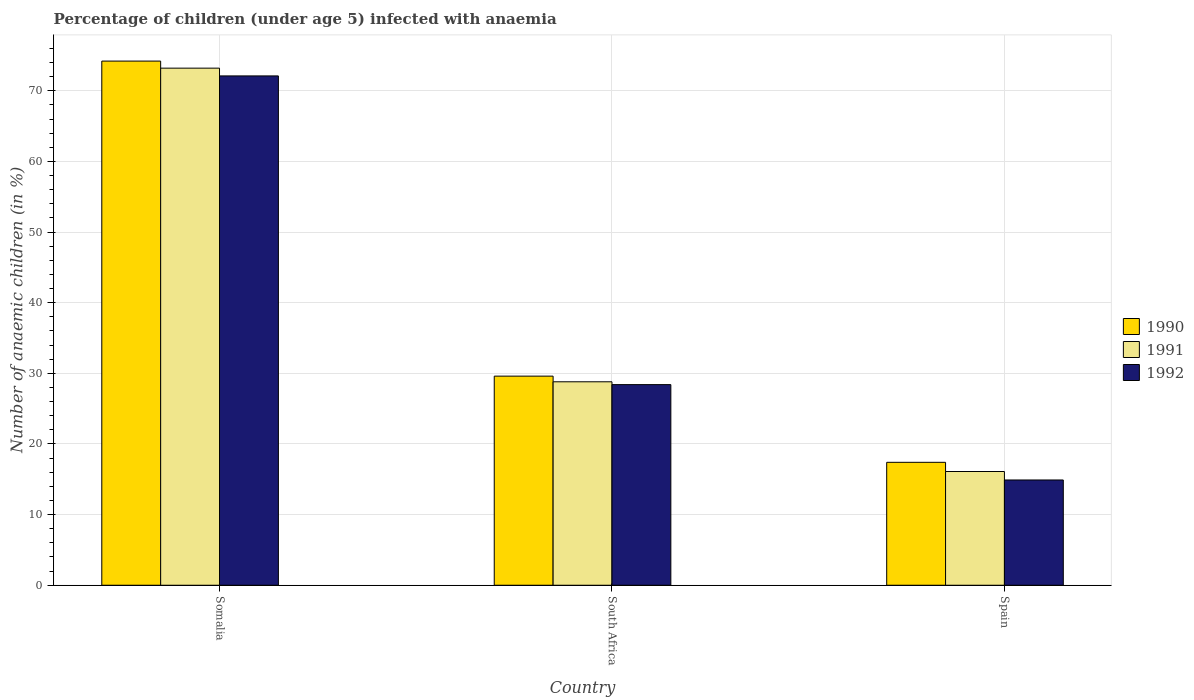How many different coloured bars are there?
Give a very brief answer. 3. How many groups of bars are there?
Ensure brevity in your answer.  3. Are the number of bars on each tick of the X-axis equal?
Your answer should be very brief. Yes. How many bars are there on the 1st tick from the left?
Make the answer very short. 3. How many bars are there on the 2nd tick from the right?
Offer a terse response. 3. What is the label of the 2nd group of bars from the left?
Keep it short and to the point. South Africa. In how many cases, is the number of bars for a given country not equal to the number of legend labels?
Make the answer very short. 0. What is the percentage of children infected with anaemia in in 1990 in South Africa?
Your answer should be very brief. 29.6. Across all countries, what is the maximum percentage of children infected with anaemia in in 1990?
Your response must be concise. 74.2. In which country was the percentage of children infected with anaemia in in 1991 maximum?
Ensure brevity in your answer.  Somalia. In which country was the percentage of children infected with anaemia in in 1990 minimum?
Make the answer very short. Spain. What is the total percentage of children infected with anaemia in in 1990 in the graph?
Give a very brief answer. 121.2. What is the difference between the percentage of children infected with anaemia in in 1992 in Somalia and that in Spain?
Offer a very short reply. 57.2. What is the difference between the percentage of children infected with anaemia in in 1991 in Somalia and the percentage of children infected with anaemia in in 1992 in South Africa?
Your response must be concise. 44.8. What is the average percentage of children infected with anaemia in in 1990 per country?
Provide a succinct answer. 40.4. What is the difference between the percentage of children infected with anaemia in of/in 1991 and percentage of children infected with anaemia in of/in 1992 in South Africa?
Your answer should be compact. 0.4. What is the ratio of the percentage of children infected with anaemia in in 1990 in Somalia to that in South Africa?
Your response must be concise. 2.51. What is the difference between the highest and the second highest percentage of children infected with anaemia in in 1990?
Ensure brevity in your answer.  -56.8. What is the difference between the highest and the lowest percentage of children infected with anaemia in in 1992?
Ensure brevity in your answer.  57.2. Is the sum of the percentage of children infected with anaemia in in 1992 in Somalia and Spain greater than the maximum percentage of children infected with anaemia in in 1990 across all countries?
Offer a very short reply. Yes. What does the 2nd bar from the right in Spain represents?
Your answer should be compact. 1991. How many bars are there?
Ensure brevity in your answer.  9. Are the values on the major ticks of Y-axis written in scientific E-notation?
Ensure brevity in your answer.  No. Does the graph contain any zero values?
Ensure brevity in your answer.  No. What is the title of the graph?
Give a very brief answer. Percentage of children (under age 5) infected with anaemia. What is the label or title of the Y-axis?
Your answer should be compact. Number of anaemic children (in %). What is the Number of anaemic children (in %) of 1990 in Somalia?
Keep it short and to the point. 74.2. What is the Number of anaemic children (in %) of 1991 in Somalia?
Your answer should be compact. 73.2. What is the Number of anaemic children (in %) in 1992 in Somalia?
Your answer should be compact. 72.1. What is the Number of anaemic children (in %) in 1990 in South Africa?
Ensure brevity in your answer.  29.6. What is the Number of anaemic children (in %) of 1991 in South Africa?
Offer a very short reply. 28.8. What is the Number of anaemic children (in %) of 1992 in South Africa?
Your answer should be very brief. 28.4. What is the Number of anaemic children (in %) in 1992 in Spain?
Offer a terse response. 14.9. Across all countries, what is the maximum Number of anaemic children (in %) in 1990?
Provide a succinct answer. 74.2. Across all countries, what is the maximum Number of anaemic children (in %) of 1991?
Make the answer very short. 73.2. Across all countries, what is the maximum Number of anaemic children (in %) in 1992?
Your response must be concise. 72.1. Across all countries, what is the minimum Number of anaemic children (in %) in 1991?
Provide a succinct answer. 16.1. Across all countries, what is the minimum Number of anaemic children (in %) in 1992?
Keep it short and to the point. 14.9. What is the total Number of anaemic children (in %) in 1990 in the graph?
Keep it short and to the point. 121.2. What is the total Number of anaemic children (in %) of 1991 in the graph?
Provide a short and direct response. 118.1. What is the total Number of anaemic children (in %) in 1992 in the graph?
Give a very brief answer. 115.4. What is the difference between the Number of anaemic children (in %) of 1990 in Somalia and that in South Africa?
Your response must be concise. 44.6. What is the difference between the Number of anaemic children (in %) of 1991 in Somalia and that in South Africa?
Offer a terse response. 44.4. What is the difference between the Number of anaemic children (in %) in 1992 in Somalia and that in South Africa?
Provide a short and direct response. 43.7. What is the difference between the Number of anaemic children (in %) of 1990 in Somalia and that in Spain?
Provide a short and direct response. 56.8. What is the difference between the Number of anaemic children (in %) of 1991 in Somalia and that in Spain?
Your response must be concise. 57.1. What is the difference between the Number of anaemic children (in %) in 1992 in Somalia and that in Spain?
Make the answer very short. 57.2. What is the difference between the Number of anaemic children (in %) of 1991 in South Africa and that in Spain?
Offer a terse response. 12.7. What is the difference between the Number of anaemic children (in %) in 1992 in South Africa and that in Spain?
Your answer should be compact. 13.5. What is the difference between the Number of anaemic children (in %) in 1990 in Somalia and the Number of anaemic children (in %) in 1991 in South Africa?
Give a very brief answer. 45.4. What is the difference between the Number of anaemic children (in %) in 1990 in Somalia and the Number of anaemic children (in %) in 1992 in South Africa?
Offer a very short reply. 45.8. What is the difference between the Number of anaemic children (in %) of 1991 in Somalia and the Number of anaemic children (in %) of 1992 in South Africa?
Ensure brevity in your answer.  44.8. What is the difference between the Number of anaemic children (in %) of 1990 in Somalia and the Number of anaemic children (in %) of 1991 in Spain?
Provide a succinct answer. 58.1. What is the difference between the Number of anaemic children (in %) of 1990 in Somalia and the Number of anaemic children (in %) of 1992 in Spain?
Provide a short and direct response. 59.3. What is the difference between the Number of anaemic children (in %) in 1991 in Somalia and the Number of anaemic children (in %) in 1992 in Spain?
Your answer should be compact. 58.3. What is the average Number of anaemic children (in %) of 1990 per country?
Offer a terse response. 40.4. What is the average Number of anaemic children (in %) in 1991 per country?
Your response must be concise. 39.37. What is the average Number of anaemic children (in %) of 1992 per country?
Make the answer very short. 38.47. What is the difference between the Number of anaemic children (in %) in 1990 and Number of anaemic children (in %) in 1991 in Somalia?
Offer a very short reply. 1. What is the difference between the Number of anaemic children (in %) of 1990 and Number of anaemic children (in %) of 1992 in Somalia?
Your answer should be very brief. 2.1. What is the difference between the Number of anaemic children (in %) of 1990 and Number of anaemic children (in %) of 1991 in South Africa?
Provide a succinct answer. 0.8. What is the difference between the Number of anaemic children (in %) in 1990 and Number of anaemic children (in %) in 1992 in South Africa?
Ensure brevity in your answer.  1.2. What is the difference between the Number of anaemic children (in %) of 1991 and Number of anaemic children (in %) of 1992 in South Africa?
Offer a terse response. 0.4. What is the difference between the Number of anaemic children (in %) in 1990 and Number of anaemic children (in %) in 1992 in Spain?
Make the answer very short. 2.5. What is the ratio of the Number of anaemic children (in %) of 1990 in Somalia to that in South Africa?
Give a very brief answer. 2.51. What is the ratio of the Number of anaemic children (in %) in 1991 in Somalia to that in South Africa?
Offer a terse response. 2.54. What is the ratio of the Number of anaemic children (in %) of 1992 in Somalia to that in South Africa?
Offer a very short reply. 2.54. What is the ratio of the Number of anaemic children (in %) of 1990 in Somalia to that in Spain?
Your answer should be compact. 4.26. What is the ratio of the Number of anaemic children (in %) in 1991 in Somalia to that in Spain?
Keep it short and to the point. 4.55. What is the ratio of the Number of anaemic children (in %) of 1992 in Somalia to that in Spain?
Your answer should be compact. 4.84. What is the ratio of the Number of anaemic children (in %) in 1990 in South Africa to that in Spain?
Keep it short and to the point. 1.7. What is the ratio of the Number of anaemic children (in %) of 1991 in South Africa to that in Spain?
Give a very brief answer. 1.79. What is the ratio of the Number of anaemic children (in %) in 1992 in South Africa to that in Spain?
Offer a terse response. 1.91. What is the difference between the highest and the second highest Number of anaemic children (in %) of 1990?
Keep it short and to the point. 44.6. What is the difference between the highest and the second highest Number of anaemic children (in %) of 1991?
Keep it short and to the point. 44.4. What is the difference between the highest and the second highest Number of anaemic children (in %) of 1992?
Provide a succinct answer. 43.7. What is the difference between the highest and the lowest Number of anaemic children (in %) in 1990?
Ensure brevity in your answer.  56.8. What is the difference between the highest and the lowest Number of anaemic children (in %) of 1991?
Offer a terse response. 57.1. What is the difference between the highest and the lowest Number of anaemic children (in %) in 1992?
Your answer should be compact. 57.2. 